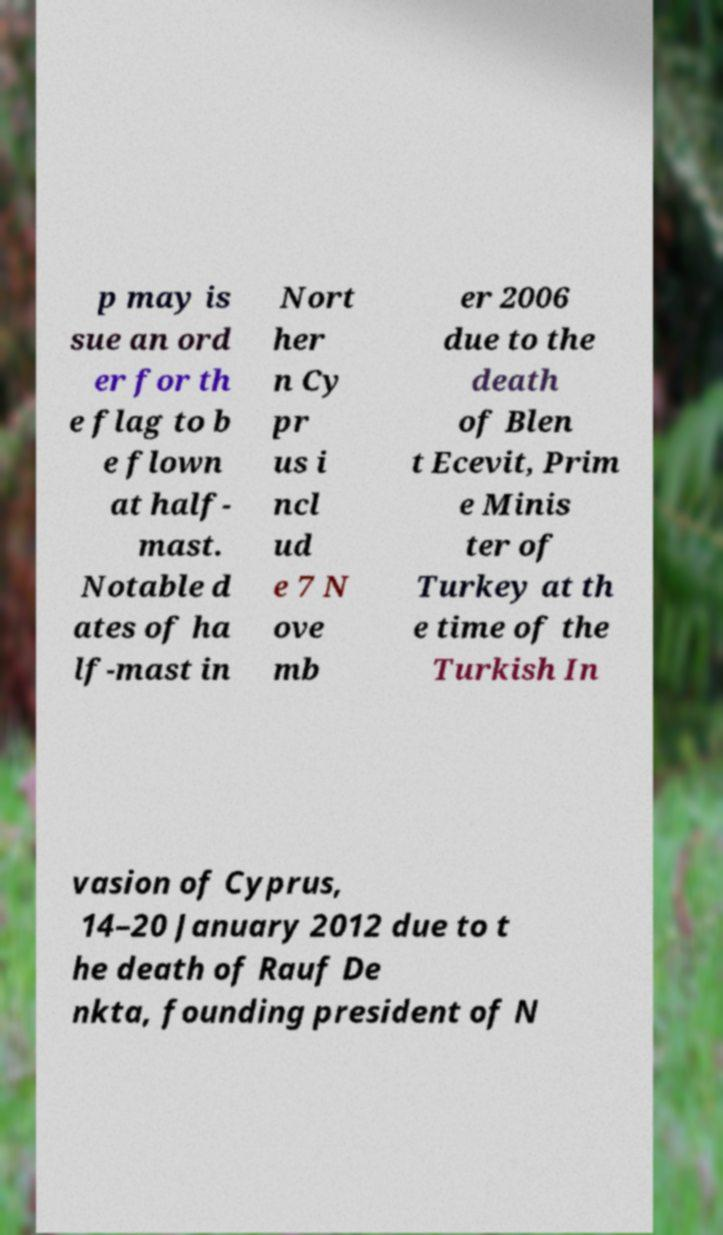For documentation purposes, I need the text within this image transcribed. Could you provide that? p may is sue an ord er for th e flag to b e flown at half- mast. Notable d ates of ha lf-mast in Nort her n Cy pr us i ncl ud e 7 N ove mb er 2006 due to the death of Blen t Ecevit, Prim e Minis ter of Turkey at th e time of the Turkish In vasion of Cyprus, 14–20 January 2012 due to t he death of Rauf De nkta, founding president of N 